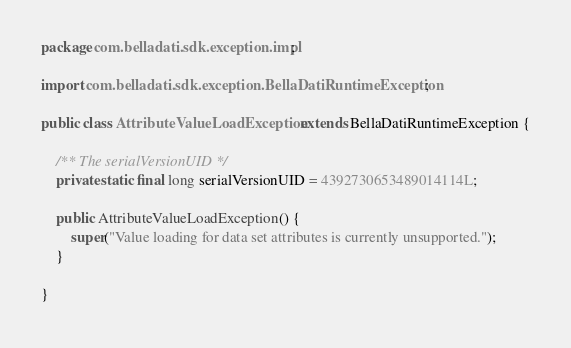Convert code to text. <code><loc_0><loc_0><loc_500><loc_500><_Java_>package com.belladati.sdk.exception.impl;

import com.belladati.sdk.exception.BellaDatiRuntimeException;

public class AttributeValueLoadException extends BellaDatiRuntimeException {

	/** The serialVersionUID */
	private static final long serialVersionUID = 4392730653489014114L;

	public AttributeValueLoadException() {
		super("Value loading for data set attributes is currently unsupported.");
	}

}
</code> 